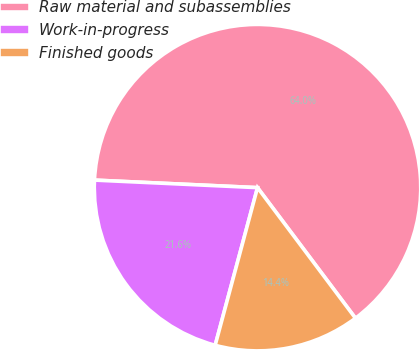Convert chart to OTSL. <chart><loc_0><loc_0><loc_500><loc_500><pie_chart><fcel>Raw material and subassemblies<fcel>Work-in-progress<fcel>Finished goods<nl><fcel>64.02%<fcel>21.56%<fcel>14.42%<nl></chart> 